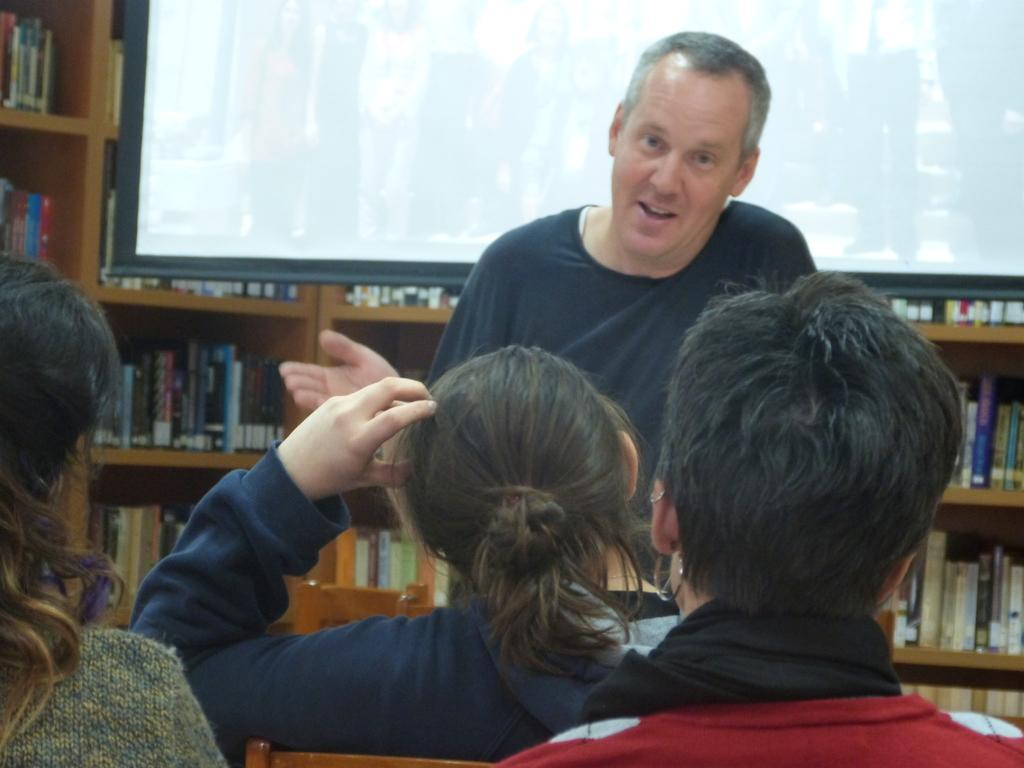How many people are in the image? There is a group of people in the image. What can be observed about the clothing of the people in the image? The people are wearing different color dresses. What is visible in the background of the image? There is a screen in the background of the image. What type of furniture is present in the background of the image? There are books inside a cupboard in the background of the image. What is the weight of the cook in the image? There is no cook present in the image, so it is not possible to determine their weight. 